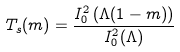Convert formula to latex. <formula><loc_0><loc_0><loc_500><loc_500>T _ { s } ( m ) = \frac { I _ { 0 } ^ { 2 } \left ( \Lambda ( 1 - m ) \right ) } { I _ { 0 } ^ { 2 } ( \Lambda ) }</formula> 